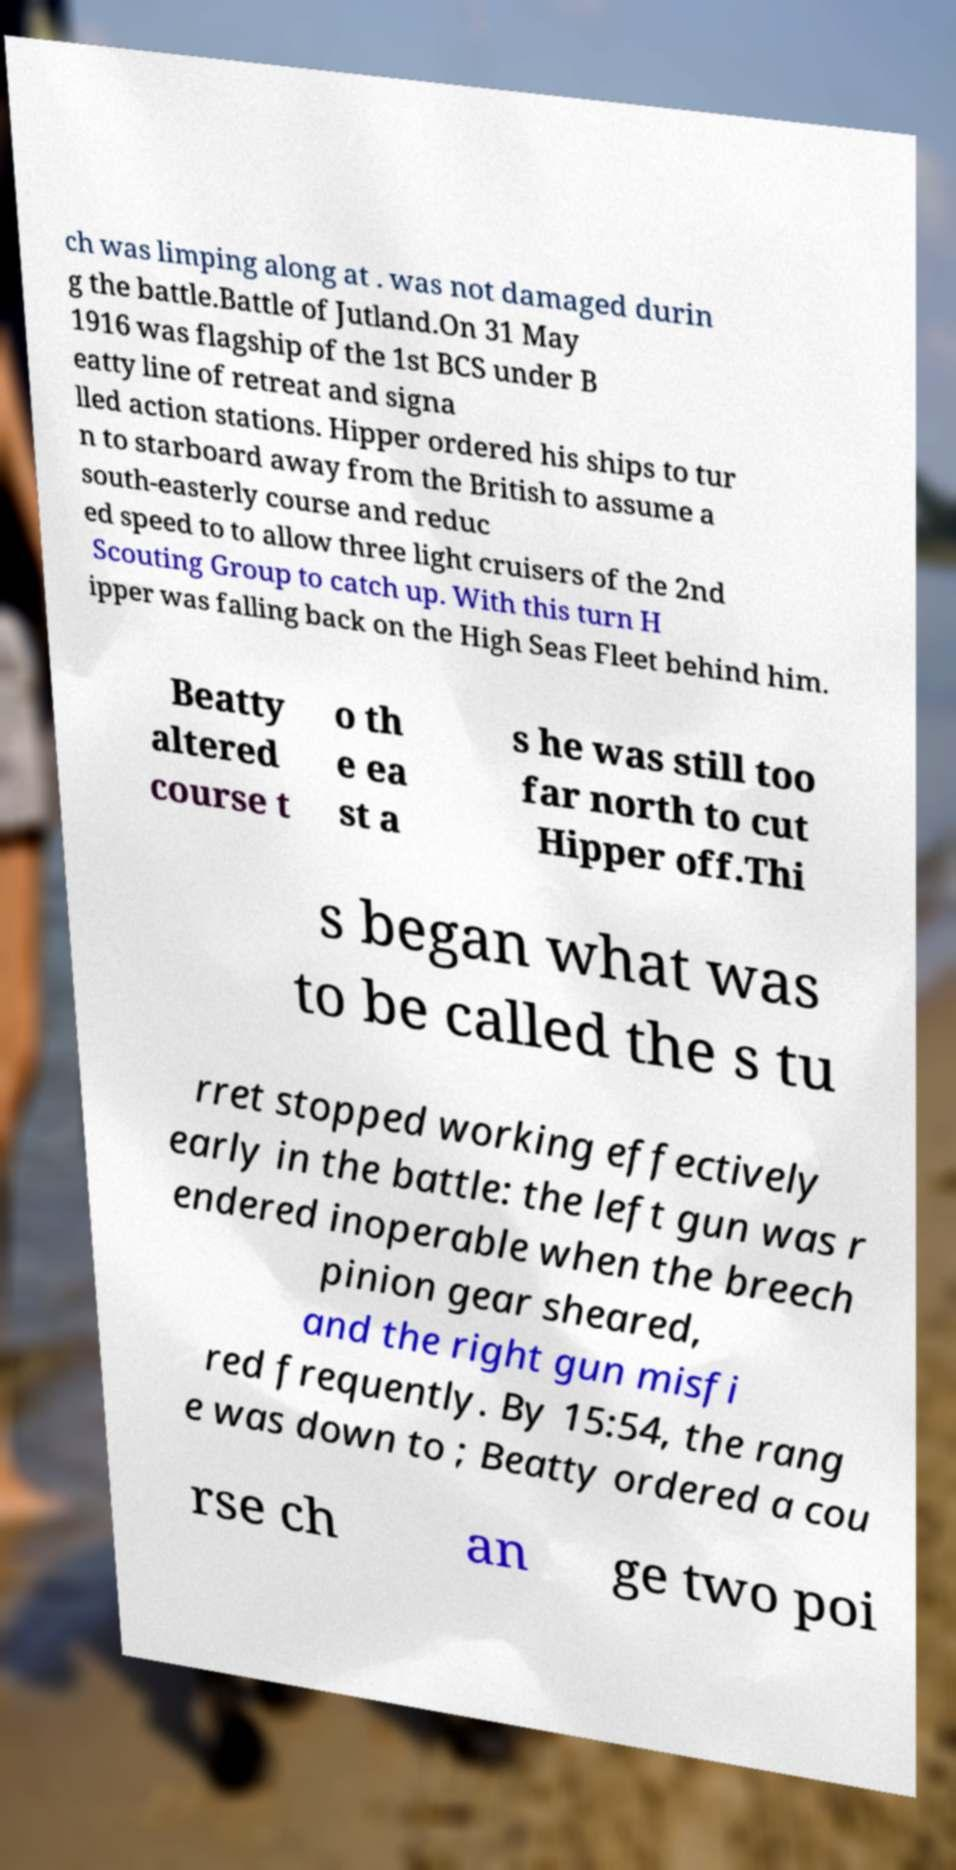Please read and relay the text visible in this image. What does it say? ch was limping along at . was not damaged durin g the battle.Battle of Jutland.On 31 May 1916 was flagship of the 1st BCS under B eatty line of retreat and signa lled action stations. Hipper ordered his ships to tur n to starboard away from the British to assume a south-easterly course and reduc ed speed to to allow three light cruisers of the 2nd Scouting Group to catch up. With this turn H ipper was falling back on the High Seas Fleet behind him. Beatty altered course t o th e ea st a s he was still too far north to cut Hipper off.Thi s began what was to be called the s tu rret stopped working effectively early in the battle: the left gun was r endered inoperable when the breech pinion gear sheared, and the right gun misfi red frequently. By 15:54, the rang e was down to ; Beatty ordered a cou rse ch an ge two poi 